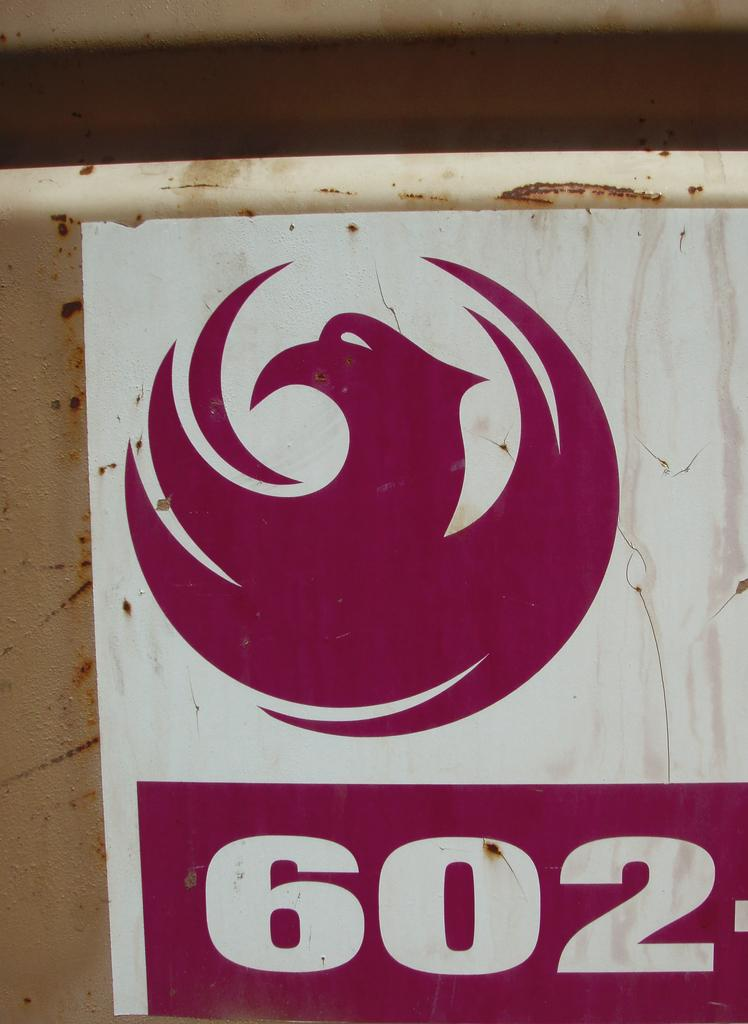<image>
Summarize the visual content of the image. A dark pink and white sign depicting the number 602 hanging on a pole. 